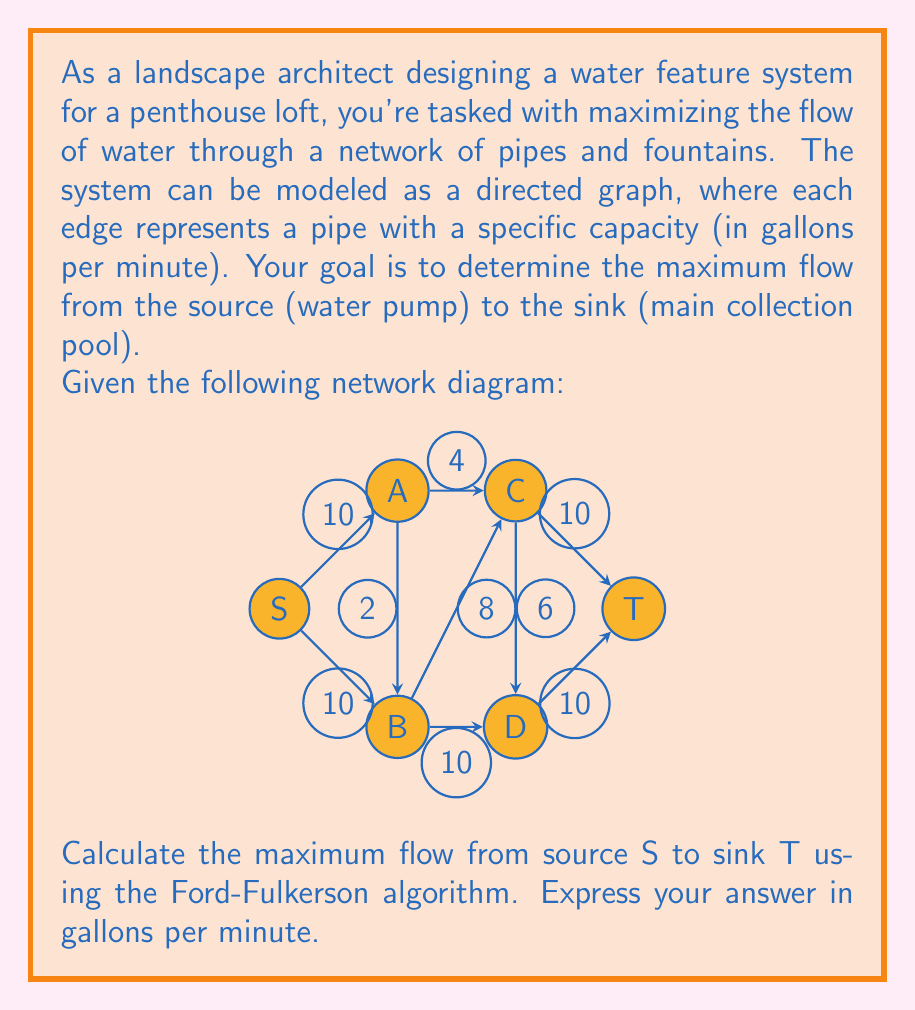What is the answer to this math problem? To solve this problem, we'll use the Ford-Fulkerson algorithm to find the maximum flow in the network. Here's a step-by-step explanation:

1) Initialize the flow to 0 for all edges.

2) While there exists an augmenting path from S to T:
   a) Find an augmenting path (e.g., using DFS or BFS)
   b) Calculate the bottleneck capacity of the path
   c) Update the flow along the path

3) Repeat step 2 until no augmenting path is found

Let's apply this algorithm to our network:

Iteration 1:
Path: S -> A -> C -> E -> T
Bottleneck: min(10, 10, 10, 10) = 10
Flow: 10

Iteration 2:
Path: S -> A -> C -> D -> T
Bottleneck: min(10, 8, 10) = 8
Flow: 18

Iteration 3:
Path: S -> B -> D -> T
Bottleneck: min(10, 4, 2) = 2
Flow: 20

Iteration 4:
Path: S -> B -> C -> D -> T
Bottleneck: min(8, 2, 6, 2) = 2
Flow: 22

No more augmenting paths exist.

The maximum flow is the sum of all flows entering the sink T, which is 22 gallons per minute.

This result can be verified by observing the min-cut in the graph, which consists of the edges (B,D), (C,E), and (D,T), with a total capacity of 4 + 10 + 10 = 24. However, due to the bottleneck at (B,D), the actual maximum flow is 22.
Answer: 22 gallons per minute 